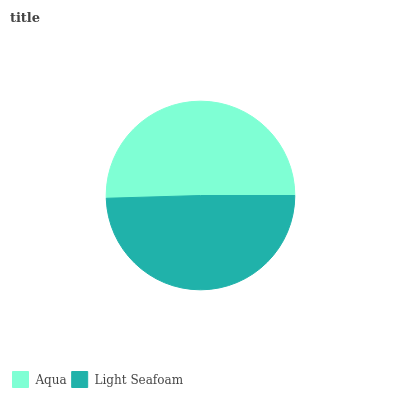Is Light Seafoam the minimum?
Answer yes or no. Yes. Is Aqua the maximum?
Answer yes or no. Yes. Is Light Seafoam the maximum?
Answer yes or no. No. Is Aqua greater than Light Seafoam?
Answer yes or no. Yes. Is Light Seafoam less than Aqua?
Answer yes or no. Yes. Is Light Seafoam greater than Aqua?
Answer yes or no. No. Is Aqua less than Light Seafoam?
Answer yes or no. No. Is Aqua the high median?
Answer yes or no. Yes. Is Light Seafoam the low median?
Answer yes or no. Yes. Is Light Seafoam the high median?
Answer yes or no. No. Is Aqua the low median?
Answer yes or no. No. 